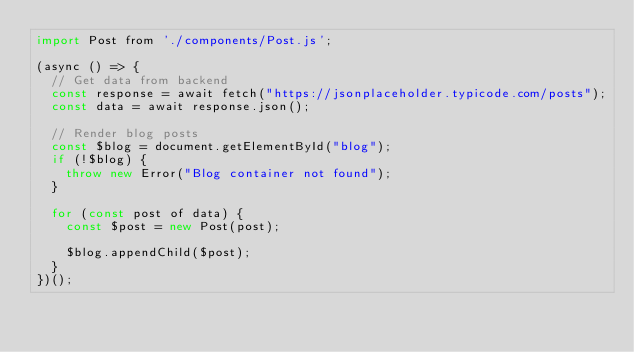Convert code to text. <code><loc_0><loc_0><loc_500><loc_500><_JavaScript_>import Post from './components/Post.js';

(async () => {
  // Get data from backend
  const response = await fetch("https://jsonplaceholder.typicode.com/posts");
  const data = await response.json();

  // Render blog posts
  const $blog = document.getElementById("blog");
  if (!$blog) {
    throw new Error("Blog container not found");
  }

  for (const post of data) {
    const $post = new Post(post);

    $blog.appendChild($post);
  }
})();
</code> 